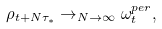<formula> <loc_0><loc_0><loc_500><loc_500>\rho _ { t + N \tau _ { * } } \rightarrow _ { N \rightarrow \infty } \omega _ { t } ^ { p e r } ,</formula> 